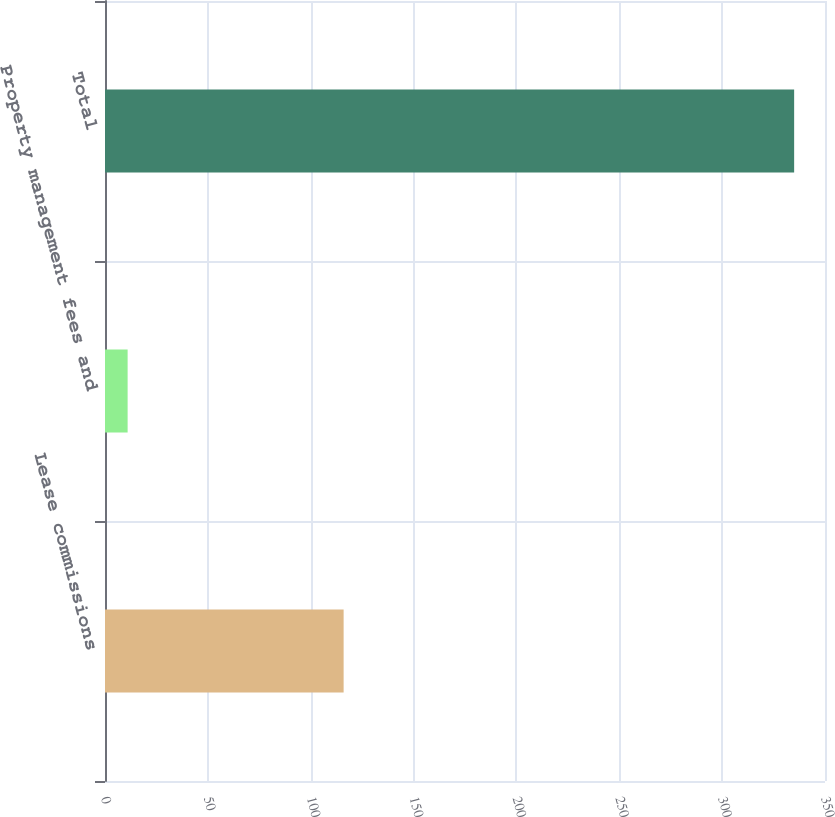Convert chart. <chart><loc_0><loc_0><loc_500><loc_500><bar_chart><fcel>Lease commissions<fcel>Property management fees and<fcel>Total<nl><fcel>116<fcel>11<fcel>335<nl></chart> 